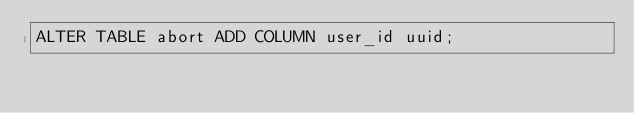<code> <loc_0><loc_0><loc_500><loc_500><_SQL_>ALTER TABLE abort ADD COLUMN user_id uuid;</code> 